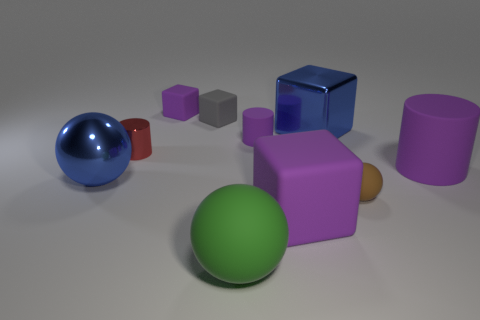What number of rubber objects are either tiny gray objects or purple balls?
Provide a succinct answer. 1. There is a tiny cylinder that is behind the metallic cylinder; how many big metallic spheres are on the left side of it?
Your response must be concise. 1. The large object that is both left of the tiny purple cylinder and behind the small brown matte ball has what shape?
Your answer should be compact. Sphere. What material is the large blue thing that is on the right side of the purple matte cylinder on the left side of the big purple rubber object that is behind the blue ball made of?
Offer a very short reply. Metal. What is the size of the other cylinder that is the same color as the large matte cylinder?
Give a very brief answer. Small. What material is the red object?
Your answer should be compact. Metal. Do the big cylinder and the large sphere that is right of the blue sphere have the same material?
Your answer should be very brief. Yes. What color is the small cube right of the matte thing behind the small gray object?
Make the answer very short. Gray. What size is the block that is in front of the tiny gray block and behind the red shiny object?
Offer a terse response. Large. What number of other things are the same shape as the brown object?
Your response must be concise. 2. 